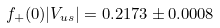<formula> <loc_0><loc_0><loc_500><loc_500>f _ { + } ( 0 ) | V _ { u s } | = 0 . 2 1 7 3 \pm 0 . 0 0 0 8</formula> 